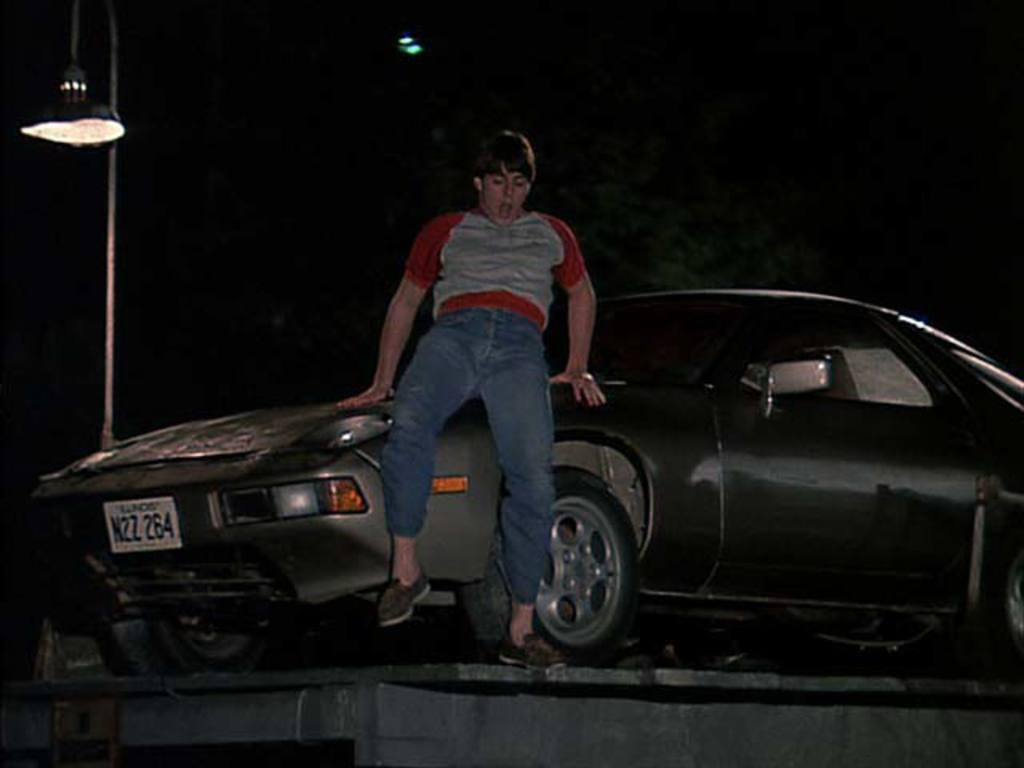What is the main subject of the image? There is a car in the image. Is there anyone inside the car? Yes, a person is sitting in the car. What can be seen in the background of the image? There is a lamp in the background of the image. How would you describe the lighting in the image? The image appears to be dark. How many lizards are crawling on the car in the image? There are no lizards present in the image. What advice would the person's uncle give them in the image? There is no mention of an uncle or any advice in the image. 